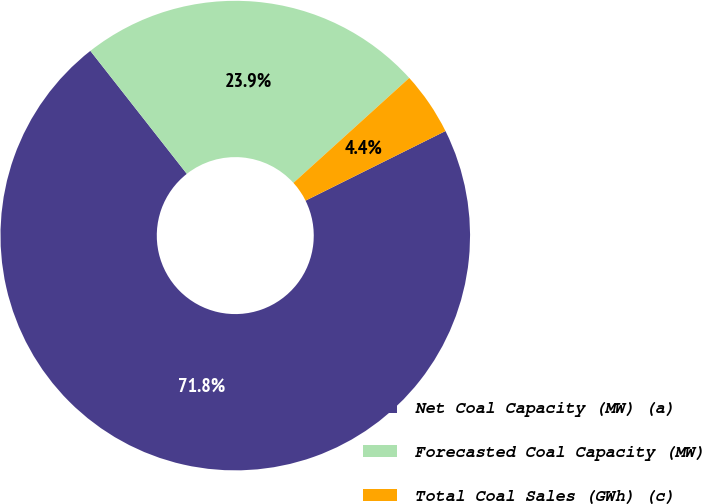Convert chart. <chart><loc_0><loc_0><loc_500><loc_500><pie_chart><fcel>Net Coal Capacity (MW) (a)<fcel>Forecasted Coal Capacity (MW)<fcel>Total Coal Sales (GWh) (c)<nl><fcel>71.76%<fcel>23.87%<fcel>4.37%<nl></chart> 